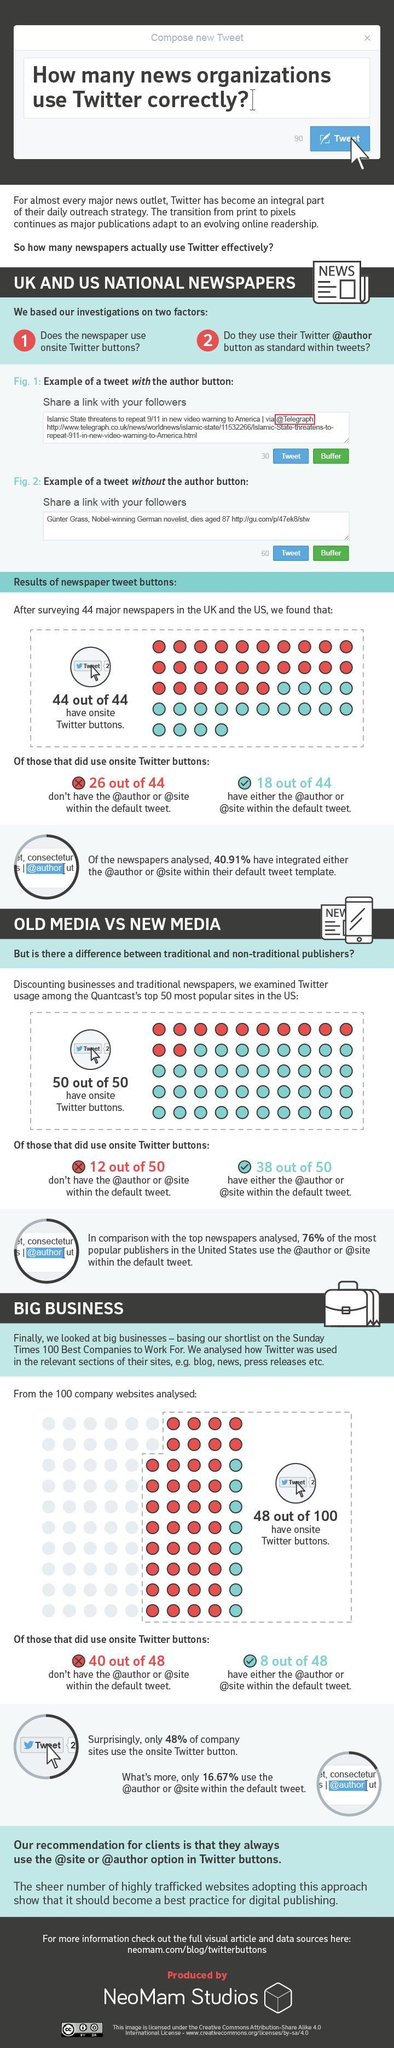What percentage of giant business leaders use Twitter for their purpose and connection?
Answer the question with a short phrase. 48 What percentage of media are using hashtags in their normal tweets? 76 What percentage of media are not using required hashtags in their normal tweets? 24 What percentage of News Paper companies are using required hashtags in their tweets? 40.91 What percentage of News Paper companies are not using required hashtags in their tweets? 59.09 What percentage of giant business do not have Onsite Twitter Buttons? 52 What is the background color given to the Tweet button- red, green, blue, yellow? blue 